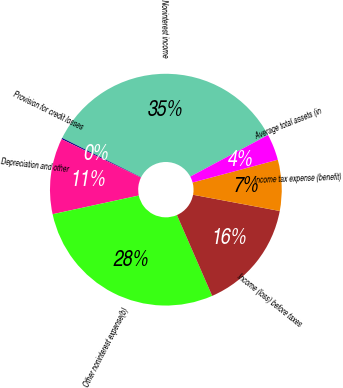Convert chart. <chart><loc_0><loc_0><loc_500><loc_500><pie_chart><fcel>Noninterest income<fcel>Provision for credit losses<fcel>Depreciation and other<fcel>Other noninterest expense(b)<fcel>Income (loss) before taxes<fcel>Income tax expense (benefit)<fcel>Average total assets (in<nl><fcel>34.83%<fcel>0.18%<fcel>10.58%<fcel>28.15%<fcel>15.51%<fcel>7.11%<fcel>3.65%<nl></chart> 